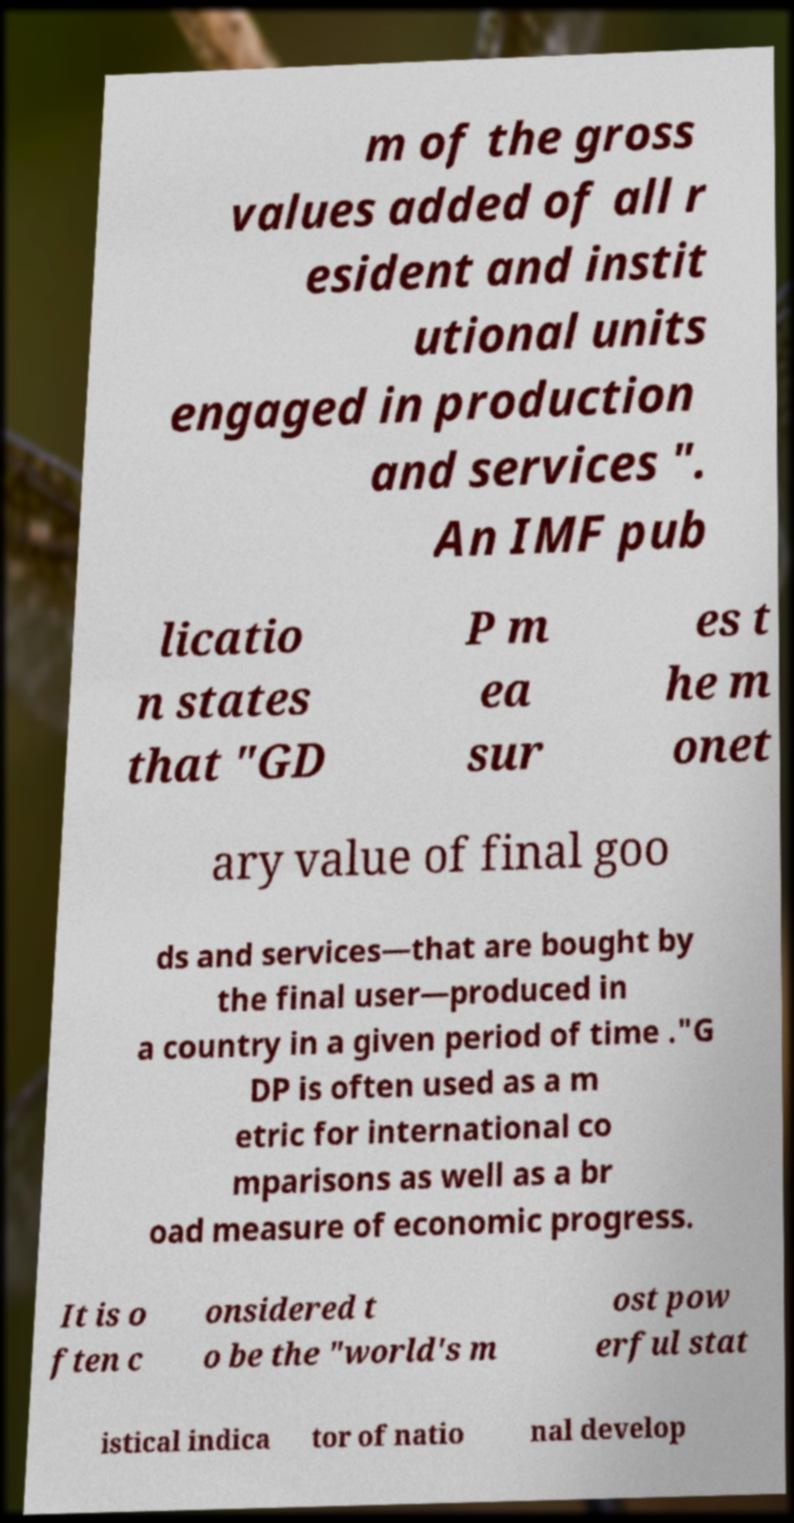For documentation purposes, I need the text within this image transcribed. Could you provide that? m of the gross values added of all r esident and instit utional units engaged in production and services ". An IMF pub licatio n states that "GD P m ea sur es t he m onet ary value of final goo ds and services—that are bought by the final user—produced in a country in a given period of time ."G DP is often used as a m etric for international co mparisons as well as a br oad measure of economic progress. It is o ften c onsidered t o be the "world's m ost pow erful stat istical indica tor of natio nal develop 